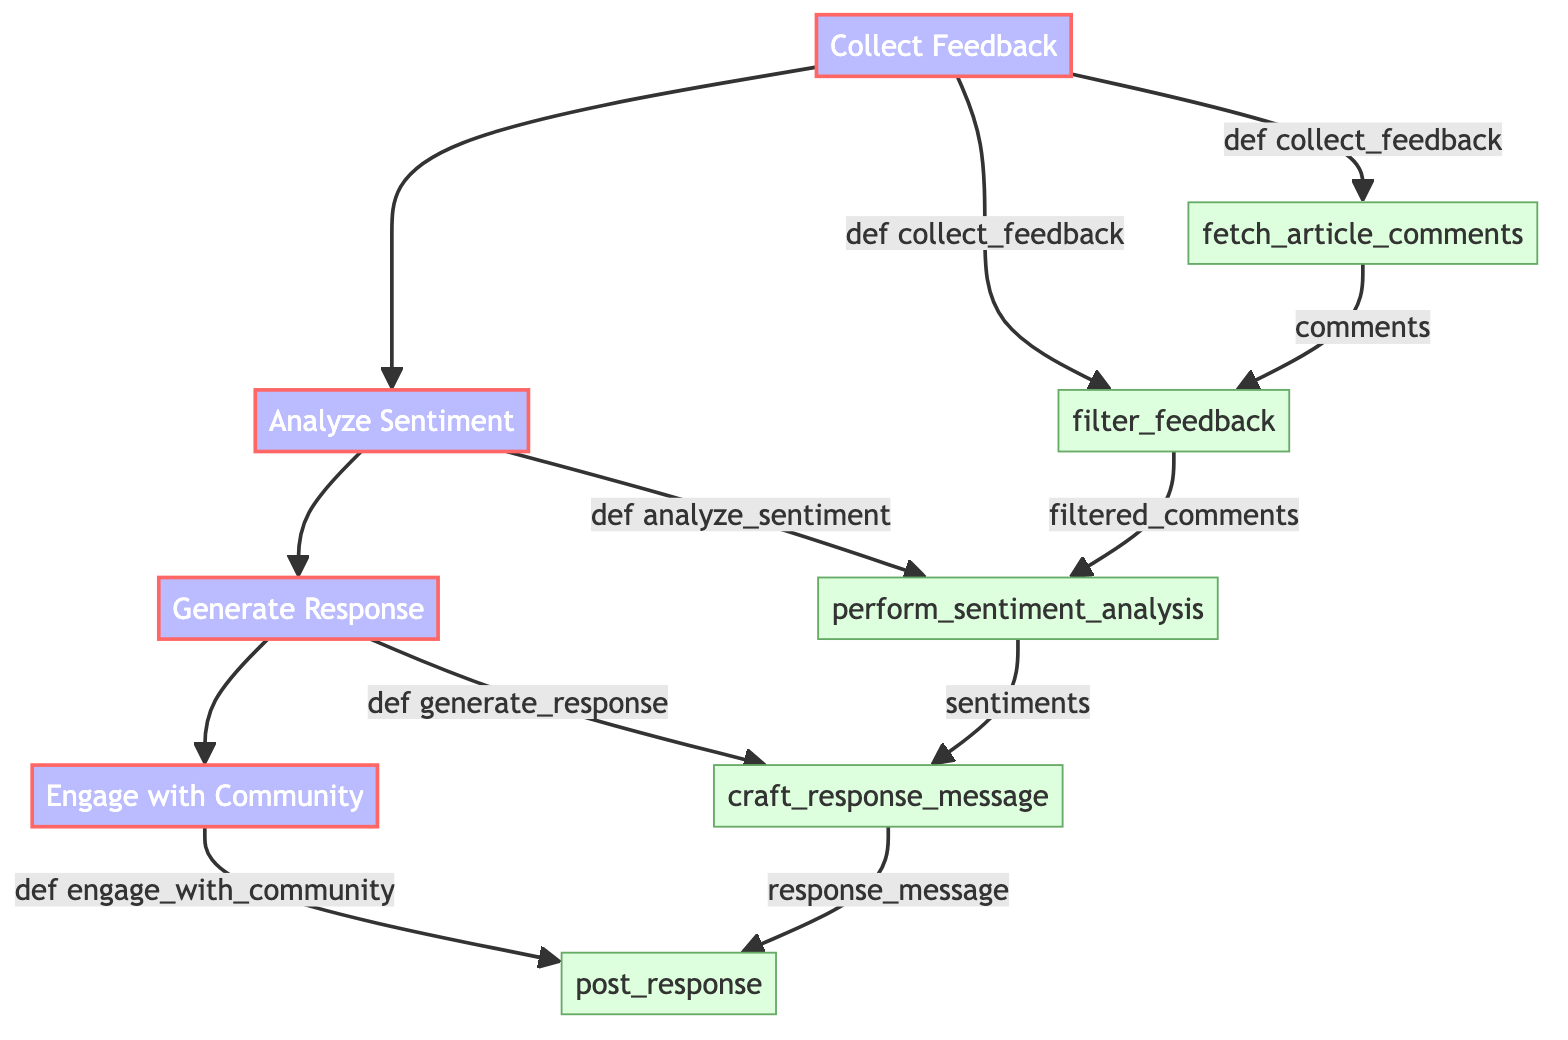What is the first step in the process? The first step in the process is "Collect Feedback," which is represented at the top of the flowchart. This step initiates the operation of gathering comments from readers.
Answer: Collect Feedback How many main steps are there in the flowchart? There are four main steps in the flowchart: "Collect Feedback," "Analyze Sentiment," "Generate Response," and "Engage with Community." These steps are connected sequentially.
Answer: Four What method is associated with the sentiment analysis step? The method associated with the sentiment analysis step is "def analyze_sentiment(filtered_comments):" which describes the function used to analyze the feedback.
Answer: def analyze_sentiment(filtered_comments): Which element follows "Generate Response"? The element that follows "Generate Response" is "Engage with Community." This indicates the next step in the process after generating a response to feedback.
Answer: Engage with Community What is the last action in the flow? The last action in the flow is "post_response," which is the action taken to publish the crafted response to engage with the community.
Answer: post_response What is the purpose of the "filter_feedback" sub-element? The purpose of the "filter_feedback" sub-element is to filter out irrelevant or inappropriate comments from the collected feedback before analysis.
Answer: Filter out irrelevant or inappropriate comments How is "filtered_comments" generated? "filtered_comments" is generated by applying the "filter_feedback" method to the comments collected from the article. The connection shows that filtered comments are derived from feedback.
Answer: By filtering comments Which platforms are specified for posting the response message? The platforms specified for posting the response message include the news portal, Facebook, Twitter, and Instagram. These are the channels where the response will be published.
Answer: News portal, Facebook, Twitter, Instagram What data does the "perform_sentiment_analysis" method receive? The "perform_sentiment_analysis" method receives "filtered_comments" as its input, which are the comments after they have been filtered for relevance and appropriateness.
Answer: filtered_comments 